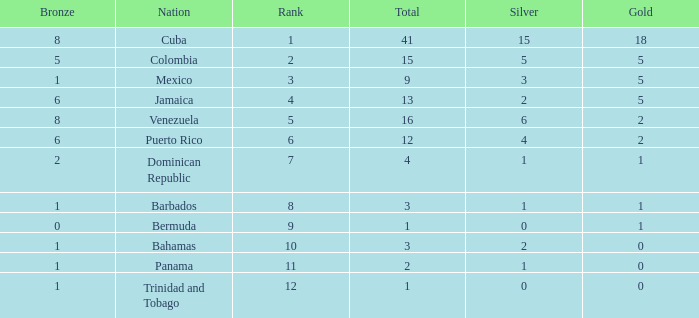Which Silver has a Gold of 2, and a Nation of puerto rico, and a Total smaller than 12? None. 